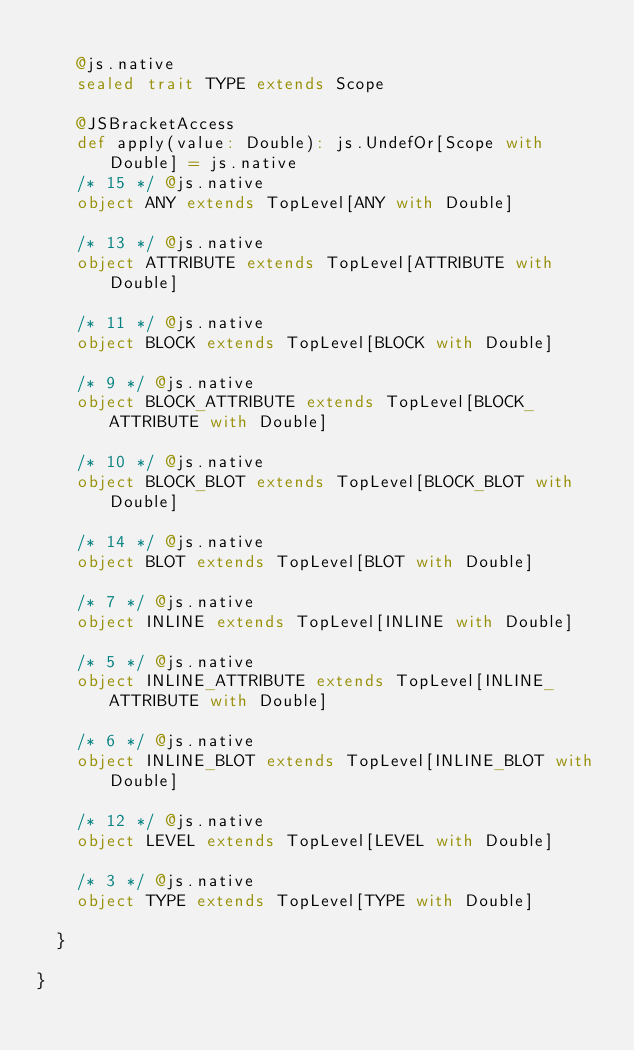<code> <loc_0><loc_0><loc_500><loc_500><_Scala_>    
    @js.native
    sealed trait TYPE extends Scope
    
    @JSBracketAccess
    def apply(value: Double): js.UndefOr[Scope with Double] = js.native
    /* 15 */ @js.native
    object ANY extends TopLevel[ANY with Double]
    
    /* 13 */ @js.native
    object ATTRIBUTE extends TopLevel[ATTRIBUTE with Double]
    
    /* 11 */ @js.native
    object BLOCK extends TopLevel[BLOCK with Double]
    
    /* 9 */ @js.native
    object BLOCK_ATTRIBUTE extends TopLevel[BLOCK_ATTRIBUTE with Double]
    
    /* 10 */ @js.native
    object BLOCK_BLOT extends TopLevel[BLOCK_BLOT with Double]
    
    /* 14 */ @js.native
    object BLOT extends TopLevel[BLOT with Double]
    
    /* 7 */ @js.native
    object INLINE extends TopLevel[INLINE with Double]
    
    /* 5 */ @js.native
    object INLINE_ATTRIBUTE extends TopLevel[INLINE_ATTRIBUTE with Double]
    
    /* 6 */ @js.native
    object INLINE_BLOT extends TopLevel[INLINE_BLOT with Double]
    
    /* 12 */ @js.native
    object LEVEL extends TopLevel[LEVEL with Double]
    
    /* 3 */ @js.native
    object TYPE extends TopLevel[TYPE with Double]
    
  }
  
}

</code> 